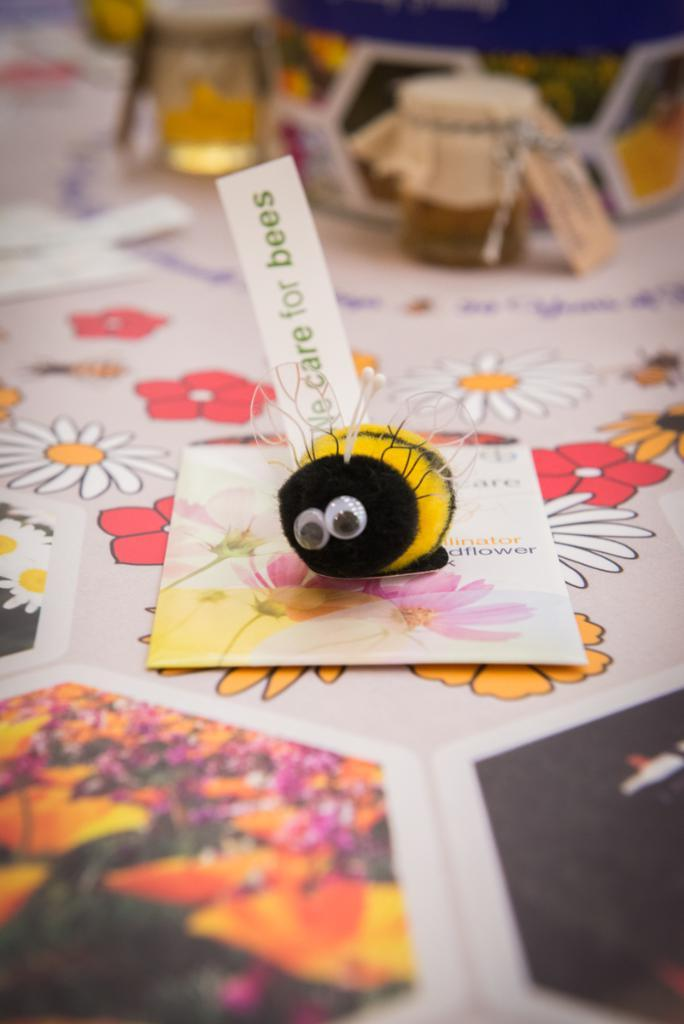<image>
Provide a brief description of the given image. A STUFFED BEE LAYING ON TOP OF A GREETING CARD THAT READS CARE FOR BEES 